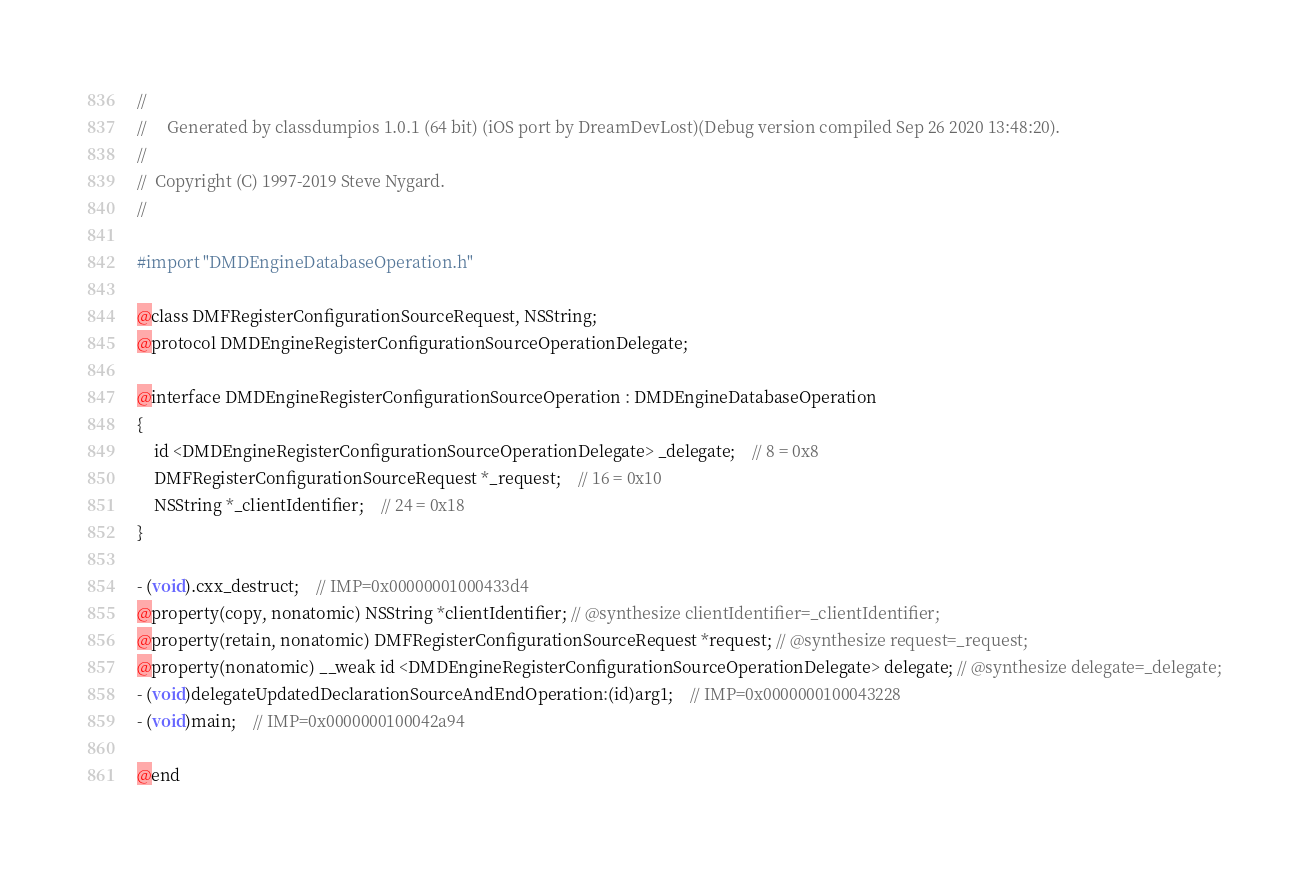Convert code to text. <code><loc_0><loc_0><loc_500><loc_500><_C_>//
//     Generated by classdumpios 1.0.1 (64 bit) (iOS port by DreamDevLost)(Debug version compiled Sep 26 2020 13:48:20).
//
//  Copyright (C) 1997-2019 Steve Nygard.
//

#import "DMDEngineDatabaseOperation.h"

@class DMFRegisterConfigurationSourceRequest, NSString;
@protocol DMDEngineRegisterConfigurationSourceOperationDelegate;

@interface DMDEngineRegisterConfigurationSourceOperation : DMDEngineDatabaseOperation
{
    id <DMDEngineRegisterConfigurationSourceOperationDelegate> _delegate;	// 8 = 0x8
    DMFRegisterConfigurationSourceRequest *_request;	// 16 = 0x10
    NSString *_clientIdentifier;	// 24 = 0x18
}

- (void).cxx_destruct;	// IMP=0x00000001000433d4
@property(copy, nonatomic) NSString *clientIdentifier; // @synthesize clientIdentifier=_clientIdentifier;
@property(retain, nonatomic) DMFRegisterConfigurationSourceRequest *request; // @synthesize request=_request;
@property(nonatomic) __weak id <DMDEngineRegisterConfigurationSourceOperationDelegate> delegate; // @synthesize delegate=_delegate;
- (void)delegateUpdatedDeclarationSourceAndEndOperation:(id)arg1;	// IMP=0x0000000100043228
- (void)main;	// IMP=0x0000000100042a94

@end

</code> 